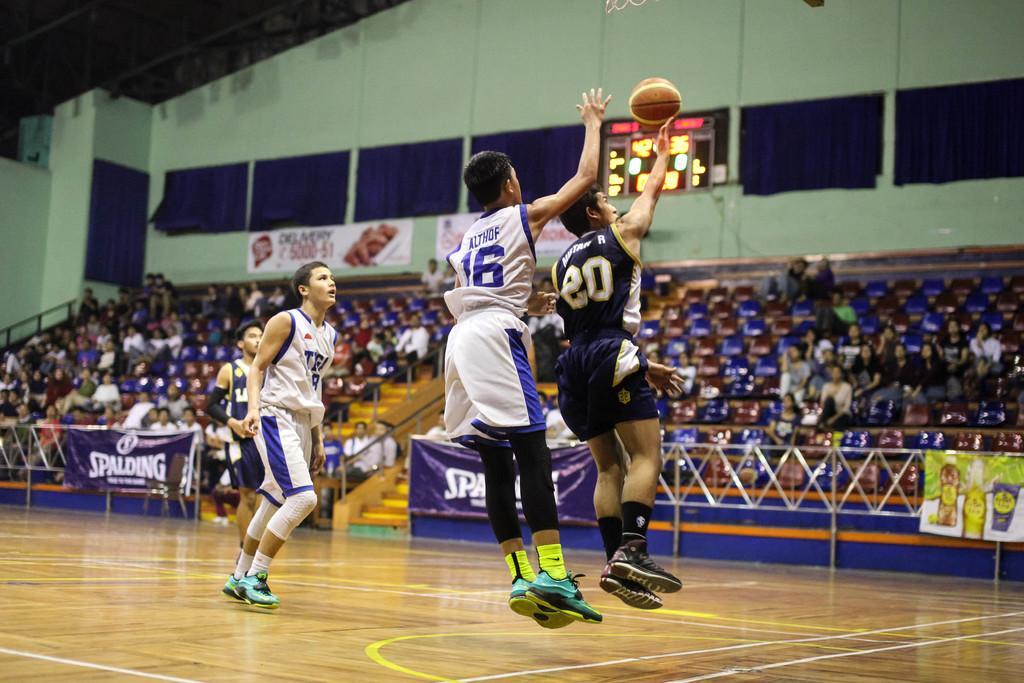How would you summarize this image in a sentence or two? In the center of the image there are people playing basketball. In the background of the image there are people sitting in stands. There is wall. At the bottom of the image there is wooden flooring. 